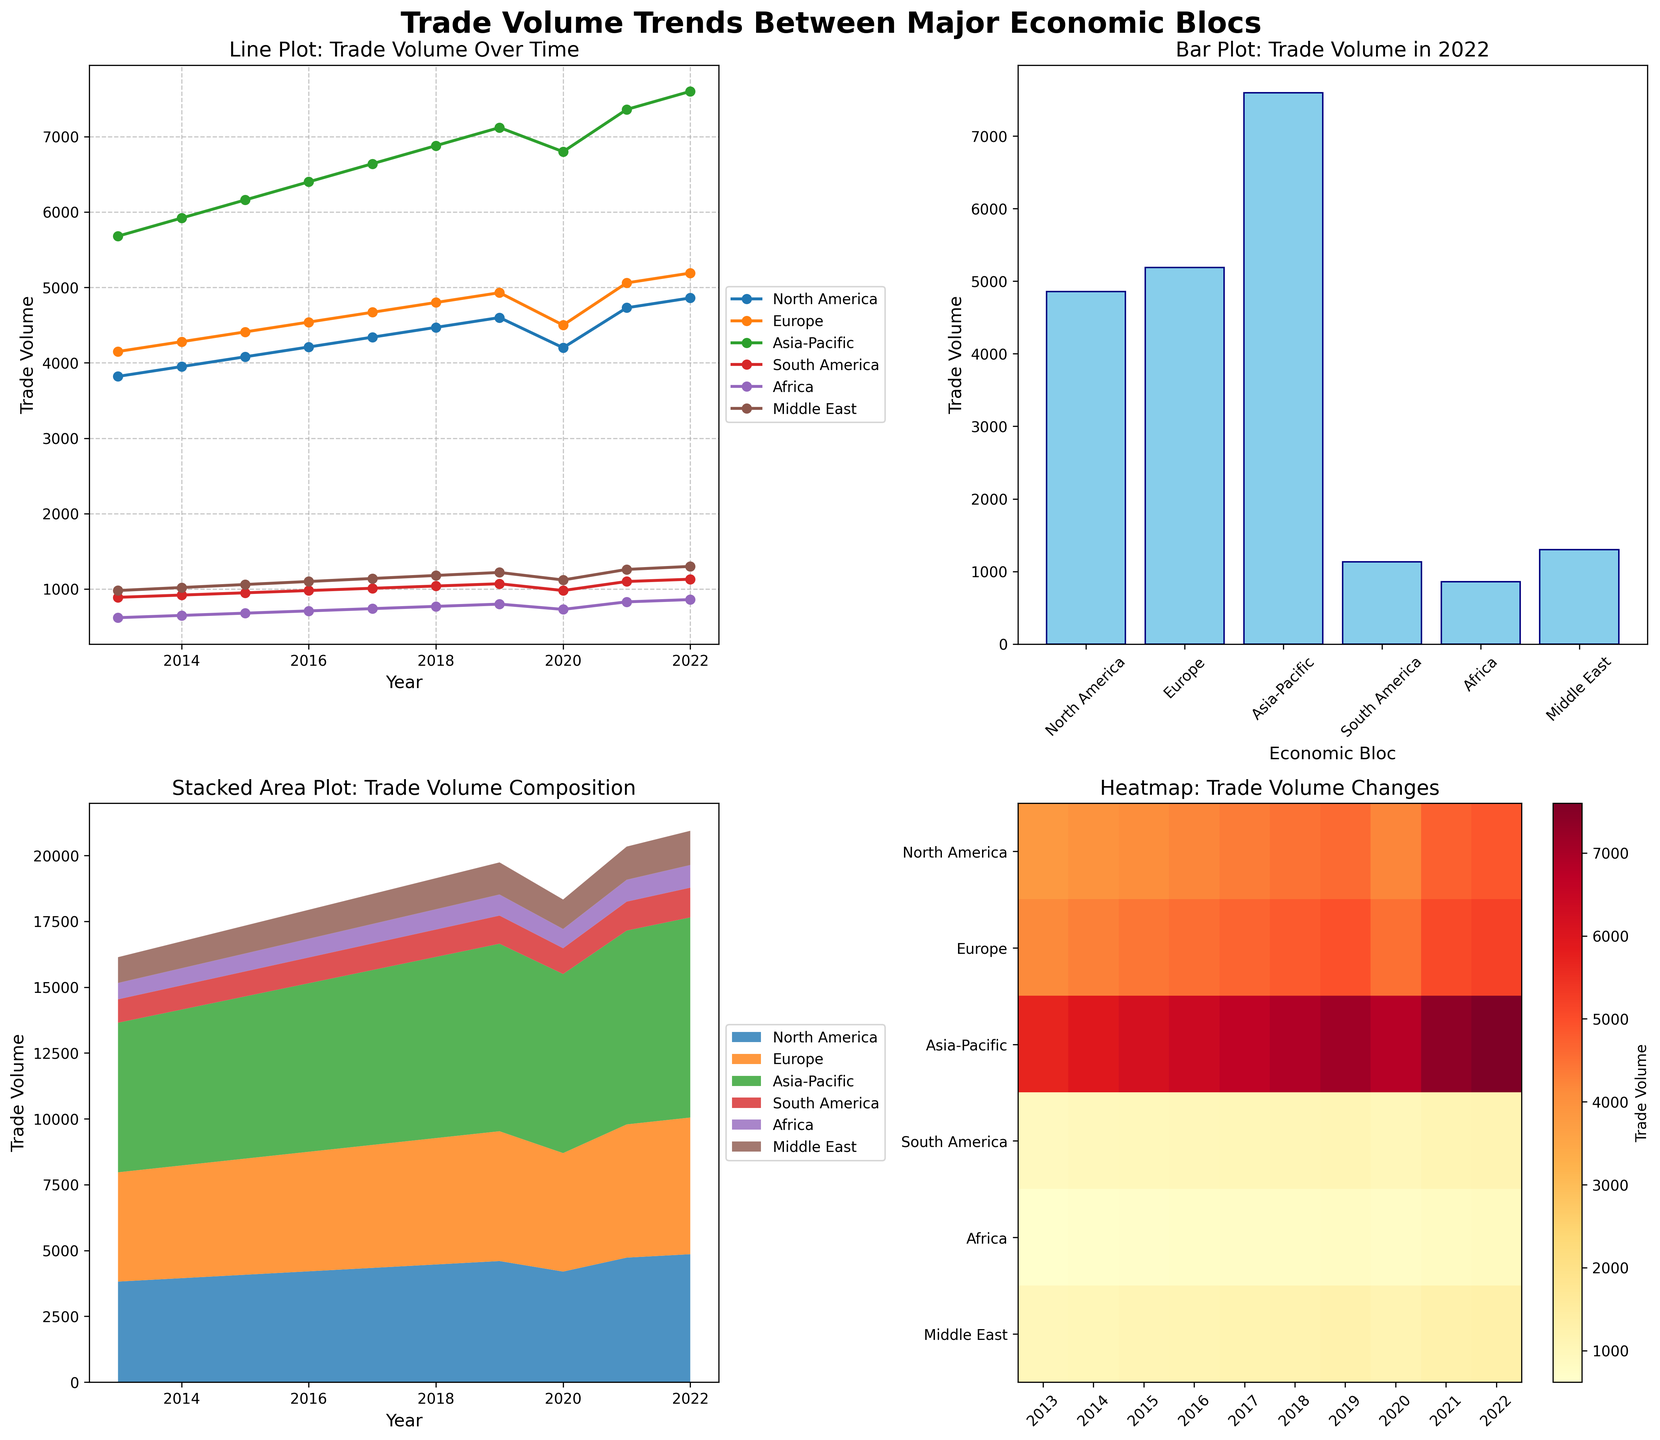What is the trade volume of North America in 2020? Look at the line plot and read the value corresponding to North America for the year 2020.
Answer: 4200 Which economic bloc had the highest trade volume in 2022? Refer to the bar plot and identify the tallest bar representing the trade volume for 2022.
Answer: Asia-Pacific Which year showed the largest increase in trade volume for Europe compared to the previous year? Observe the line plot and identify the highest year-to-year difference for Europe by comparing changes between consecutive data points.
Answer: 2021 What is the combined trade volume of South America and Africa in 2015? Refer to the data of 2015 for South America and Africa, sum their trade volumes (950 + 680).
Answer: 1630 Which economic bloc experienced the most significant decline in trade volume in 2020 compared to 2019? Check the line plot between 2019 and 2020 and find the bloc with the steepest negative slope.
Answer: Asia-Pacific How did the trade volume of the Middle East change from 2017 to 2022? Look at the line plot and read the values for the Middle East from 2017 to 2022, then calculate the difference (1300 - 1140).
Answer: Increased by 160 What pattern do you observe in the stacked area plot regarding the dominance of trade volume among economic blocs? Notice which colors dominate the stacked area plot over time and identify any persistent top contributors.
Answer: Asia-Pacific consistently has the highest share Which blocs had nearly similar trade volumes in 2016, and what were their volumes? Compare the heights of the corresponding lines in the line plot for 2016 and identify similar heights; verify with exact values.
Answer: North America (4210) and Europe (4540) What color represents the highest trade volume in the heatmap, and which year does it appear most frequently? Identify the color gradient indicating higher values and locate those regions in the heatmap.
Answer: Red; 2022 By how much did the trade volume of North America increase from 2013 to 2022? Calculate the difference in North America's trade volume between 2022 and 2013 (4860 - 3820).
Answer: 1040 